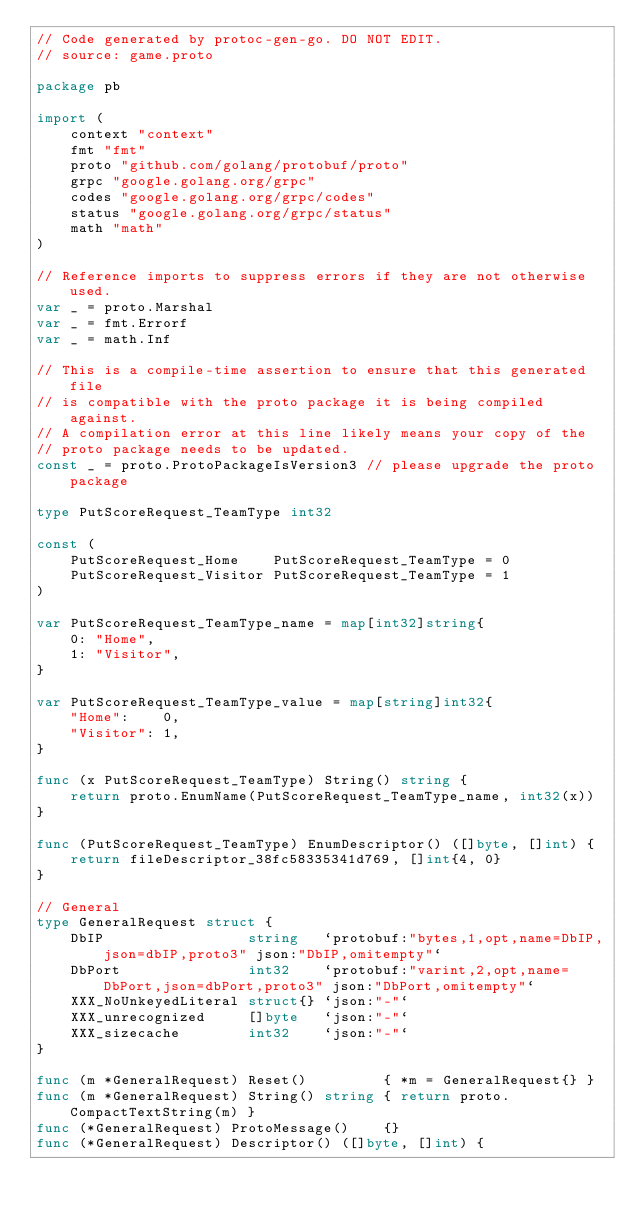Convert code to text. <code><loc_0><loc_0><loc_500><loc_500><_Go_>// Code generated by protoc-gen-go. DO NOT EDIT.
// source: game.proto

package pb

import (
	context "context"
	fmt "fmt"
	proto "github.com/golang/protobuf/proto"
	grpc "google.golang.org/grpc"
	codes "google.golang.org/grpc/codes"
	status "google.golang.org/grpc/status"
	math "math"
)

// Reference imports to suppress errors if they are not otherwise used.
var _ = proto.Marshal
var _ = fmt.Errorf
var _ = math.Inf

// This is a compile-time assertion to ensure that this generated file
// is compatible with the proto package it is being compiled against.
// A compilation error at this line likely means your copy of the
// proto package needs to be updated.
const _ = proto.ProtoPackageIsVersion3 // please upgrade the proto package

type PutScoreRequest_TeamType int32

const (
	PutScoreRequest_Home    PutScoreRequest_TeamType = 0
	PutScoreRequest_Visitor PutScoreRequest_TeamType = 1
)

var PutScoreRequest_TeamType_name = map[int32]string{
	0: "Home",
	1: "Visitor",
}

var PutScoreRequest_TeamType_value = map[string]int32{
	"Home":    0,
	"Visitor": 1,
}

func (x PutScoreRequest_TeamType) String() string {
	return proto.EnumName(PutScoreRequest_TeamType_name, int32(x))
}

func (PutScoreRequest_TeamType) EnumDescriptor() ([]byte, []int) {
	return fileDescriptor_38fc58335341d769, []int{4, 0}
}

// General
type GeneralRequest struct {
	DbIP                 string   `protobuf:"bytes,1,opt,name=DbIP,json=dbIP,proto3" json:"DbIP,omitempty"`
	DbPort               int32    `protobuf:"varint,2,opt,name=DbPort,json=dbPort,proto3" json:"DbPort,omitempty"`
	XXX_NoUnkeyedLiteral struct{} `json:"-"`
	XXX_unrecognized     []byte   `json:"-"`
	XXX_sizecache        int32    `json:"-"`
}

func (m *GeneralRequest) Reset()         { *m = GeneralRequest{} }
func (m *GeneralRequest) String() string { return proto.CompactTextString(m) }
func (*GeneralRequest) ProtoMessage()    {}
func (*GeneralRequest) Descriptor() ([]byte, []int) {</code> 